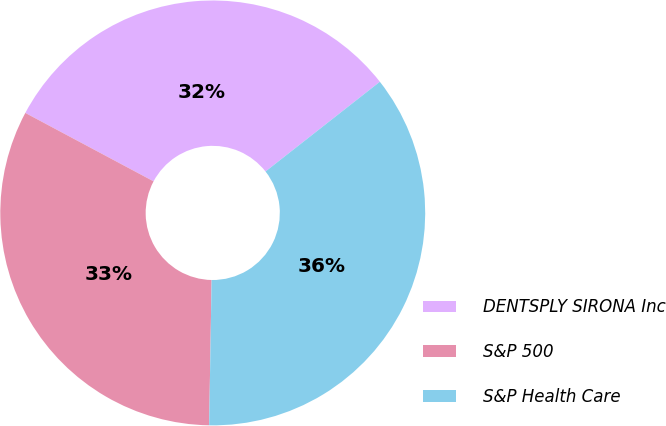Convert chart. <chart><loc_0><loc_0><loc_500><loc_500><pie_chart><fcel>DENTSPLY SIRONA Inc<fcel>S&P 500<fcel>S&P Health Care<nl><fcel>31.61%<fcel>32.53%<fcel>35.86%<nl></chart> 